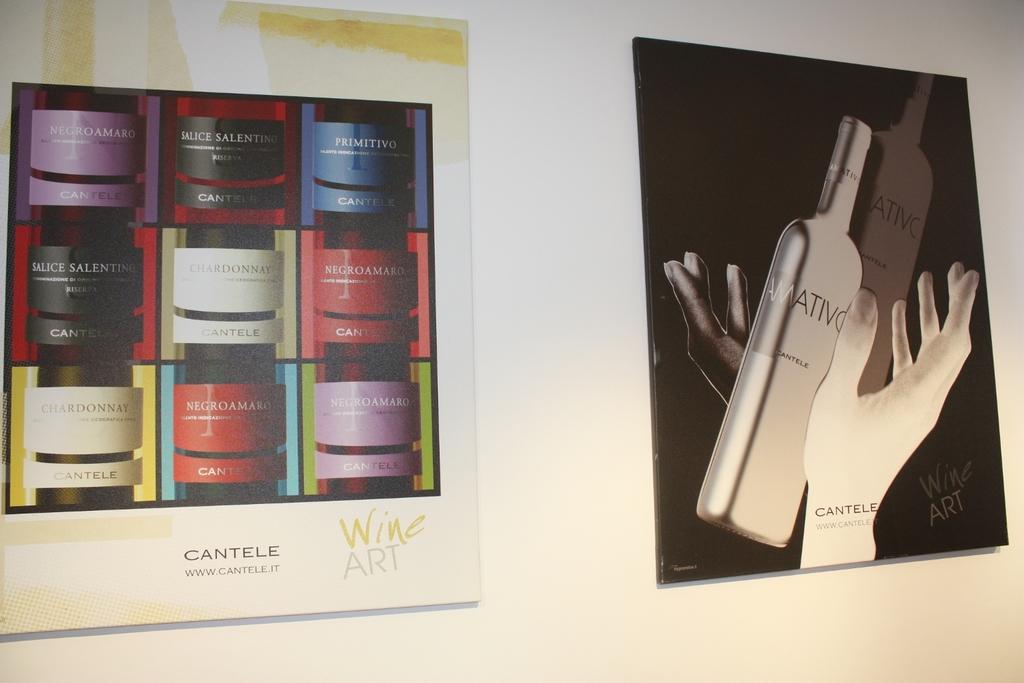What is being advertised?
Your response must be concise. Cantele. What is the brand called?
Keep it short and to the point. Cantele. 